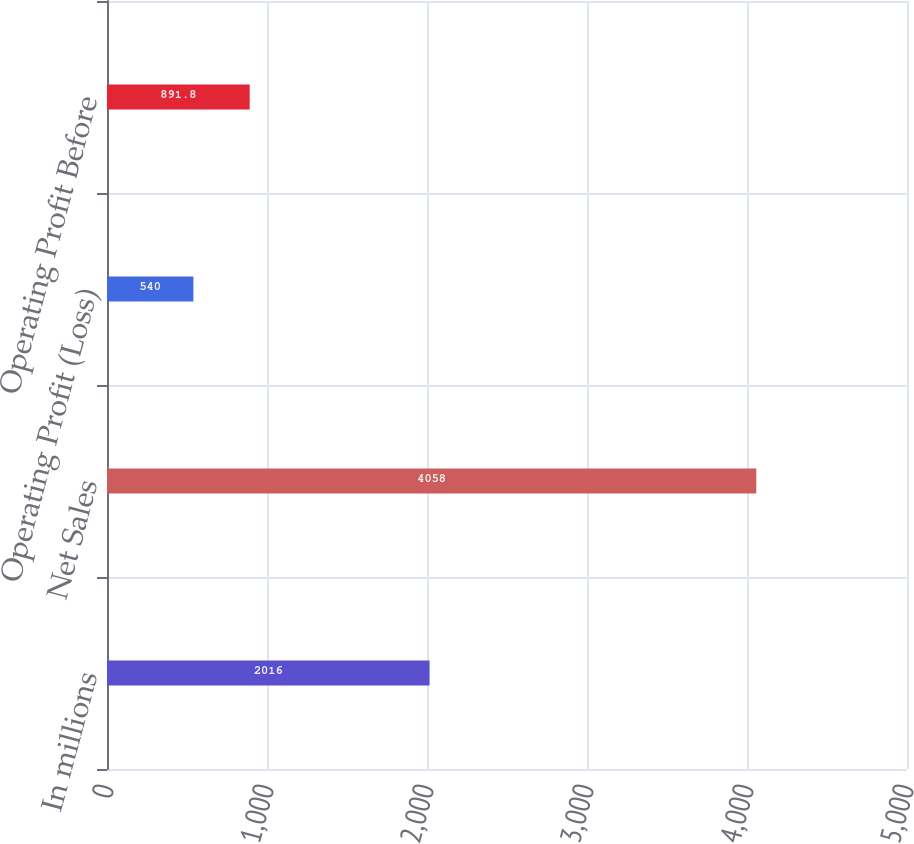Convert chart to OTSL. <chart><loc_0><loc_0><loc_500><loc_500><bar_chart><fcel>In millions<fcel>Net Sales<fcel>Operating Profit (Loss)<fcel>Operating Profit Before<nl><fcel>2016<fcel>4058<fcel>540<fcel>891.8<nl></chart> 